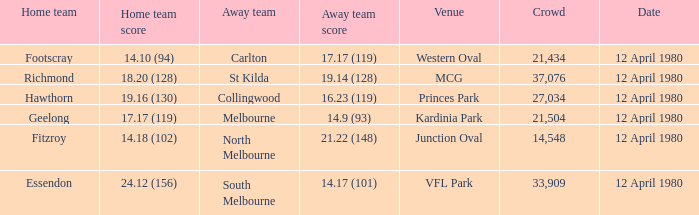Who was North Melbourne's home opponent? Fitzroy. 